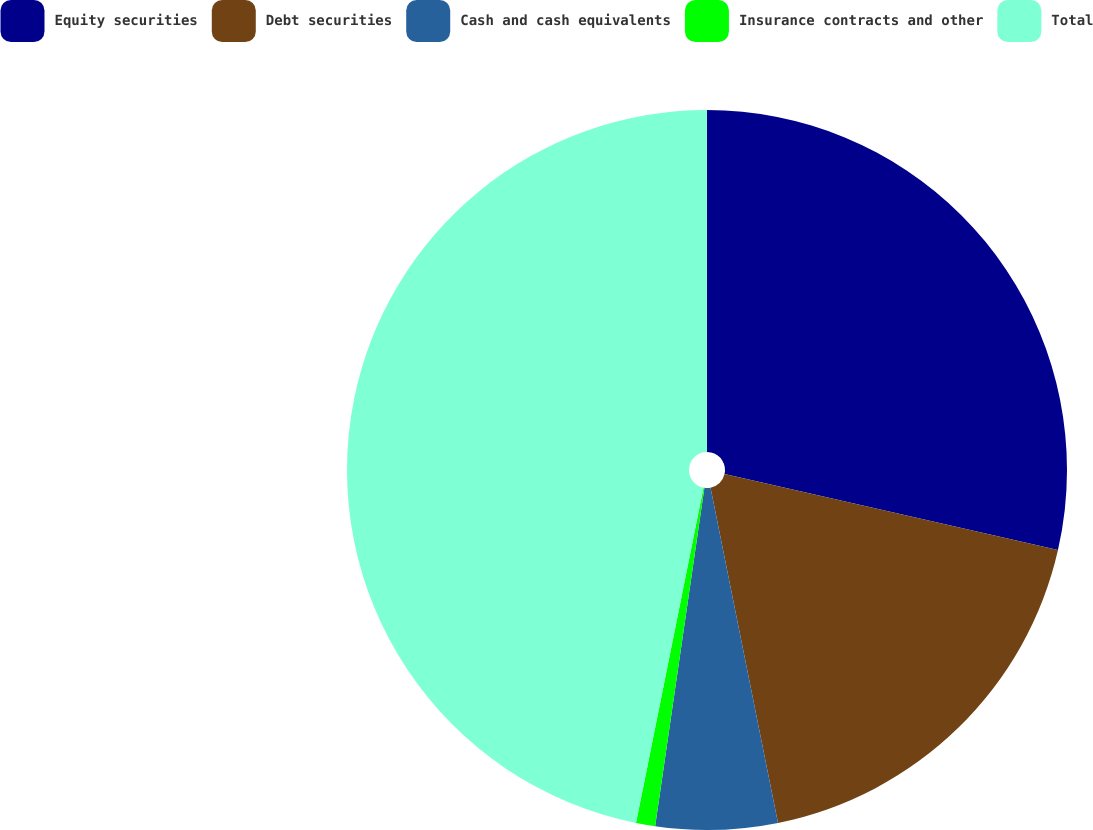Convert chart. <chart><loc_0><loc_0><loc_500><loc_500><pie_chart><fcel>Equity securities<fcel>Debt securities<fcel>Cash and cash equivalents<fcel>Insurance contracts and other<fcel>Total<nl><fcel>28.57%<fcel>18.27%<fcel>5.46%<fcel>0.86%<fcel>46.84%<nl></chart> 